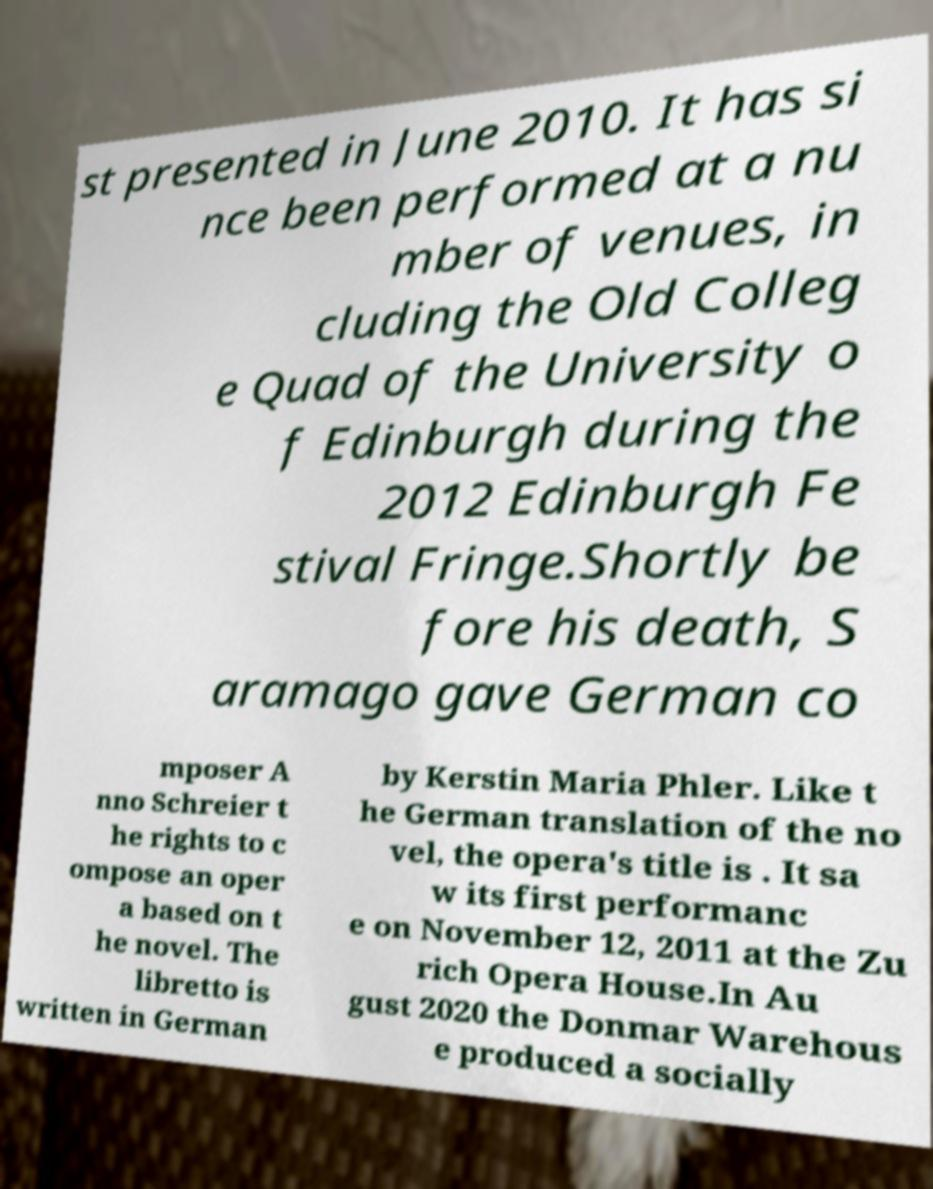Please read and relay the text visible in this image. What does it say? st presented in June 2010. It has si nce been performed at a nu mber of venues, in cluding the Old Colleg e Quad of the University o f Edinburgh during the 2012 Edinburgh Fe stival Fringe.Shortly be fore his death, S aramago gave German co mposer A nno Schreier t he rights to c ompose an oper a based on t he novel. The libretto is written in German by Kerstin Maria Phler. Like t he German translation of the no vel, the opera's title is . It sa w its first performanc e on November 12, 2011 at the Zu rich Opera House.In Au gust 2020 the Donmar Warehous e produced a socially 